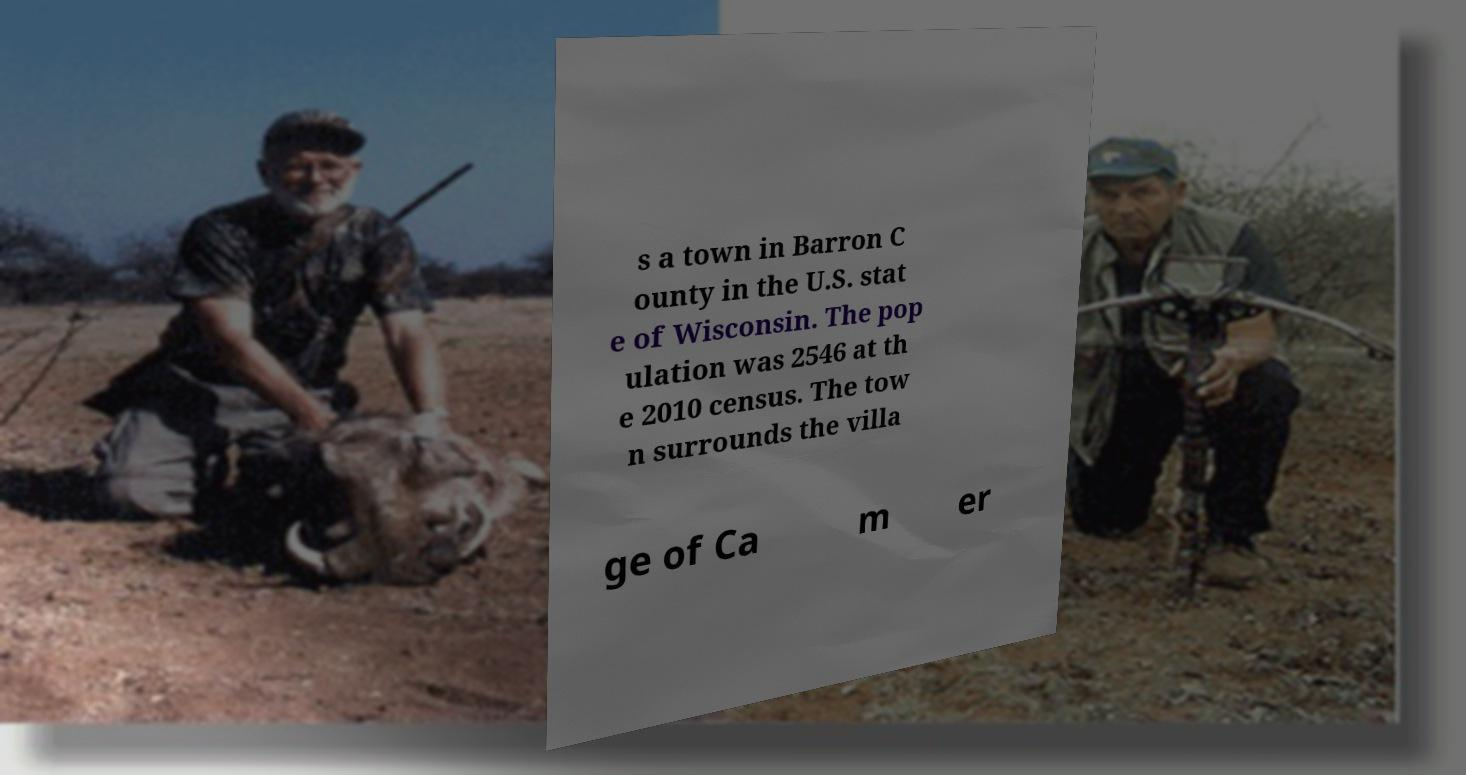For documentation purposes, I need the text within this image transcribed. Could you provide that? s a town in Barron C ounty in the U.S. stat e of Wisconsin. The pop ulation was 2546 at th e 2010 census. The tow n surrounds the villa ge of Ca m er 